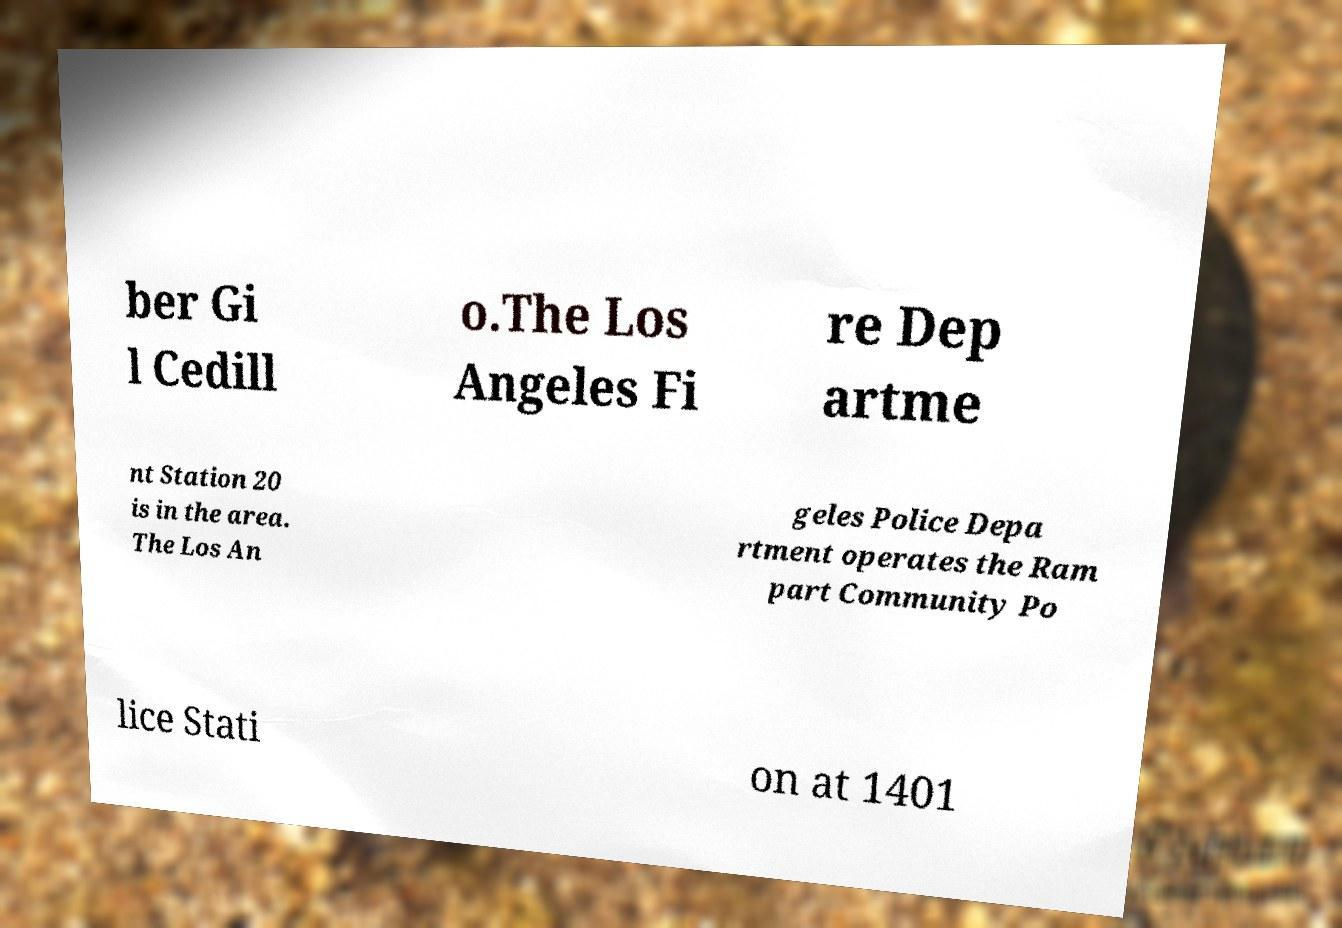Can you read and provide the text displayed in the image?This photo seems to have some interesting text. Can you extract and type it out for me? ber Gi l Cedill o.The Los Angeles Fi re Dep artme nt Station 20 is in the area. The Los An geles Police Depa rtment operates the Ram part Community Po lice Stati on at 1401 